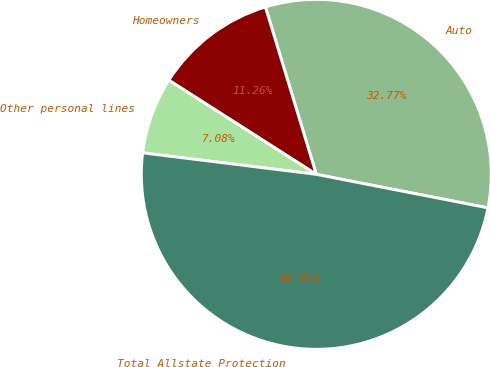Convert chart to OTSL. <chart><loc_0><loc_0><loc_500><loc_500><pie_chart><fcel>Auto<fcel>Homeowners<fcel>Other personal lines<fcel>Total Allstate Protection<nl><fcel>32.77%<fcel>11.26%<fcel>7.08%<fcel>48.9%<nl></chart> 